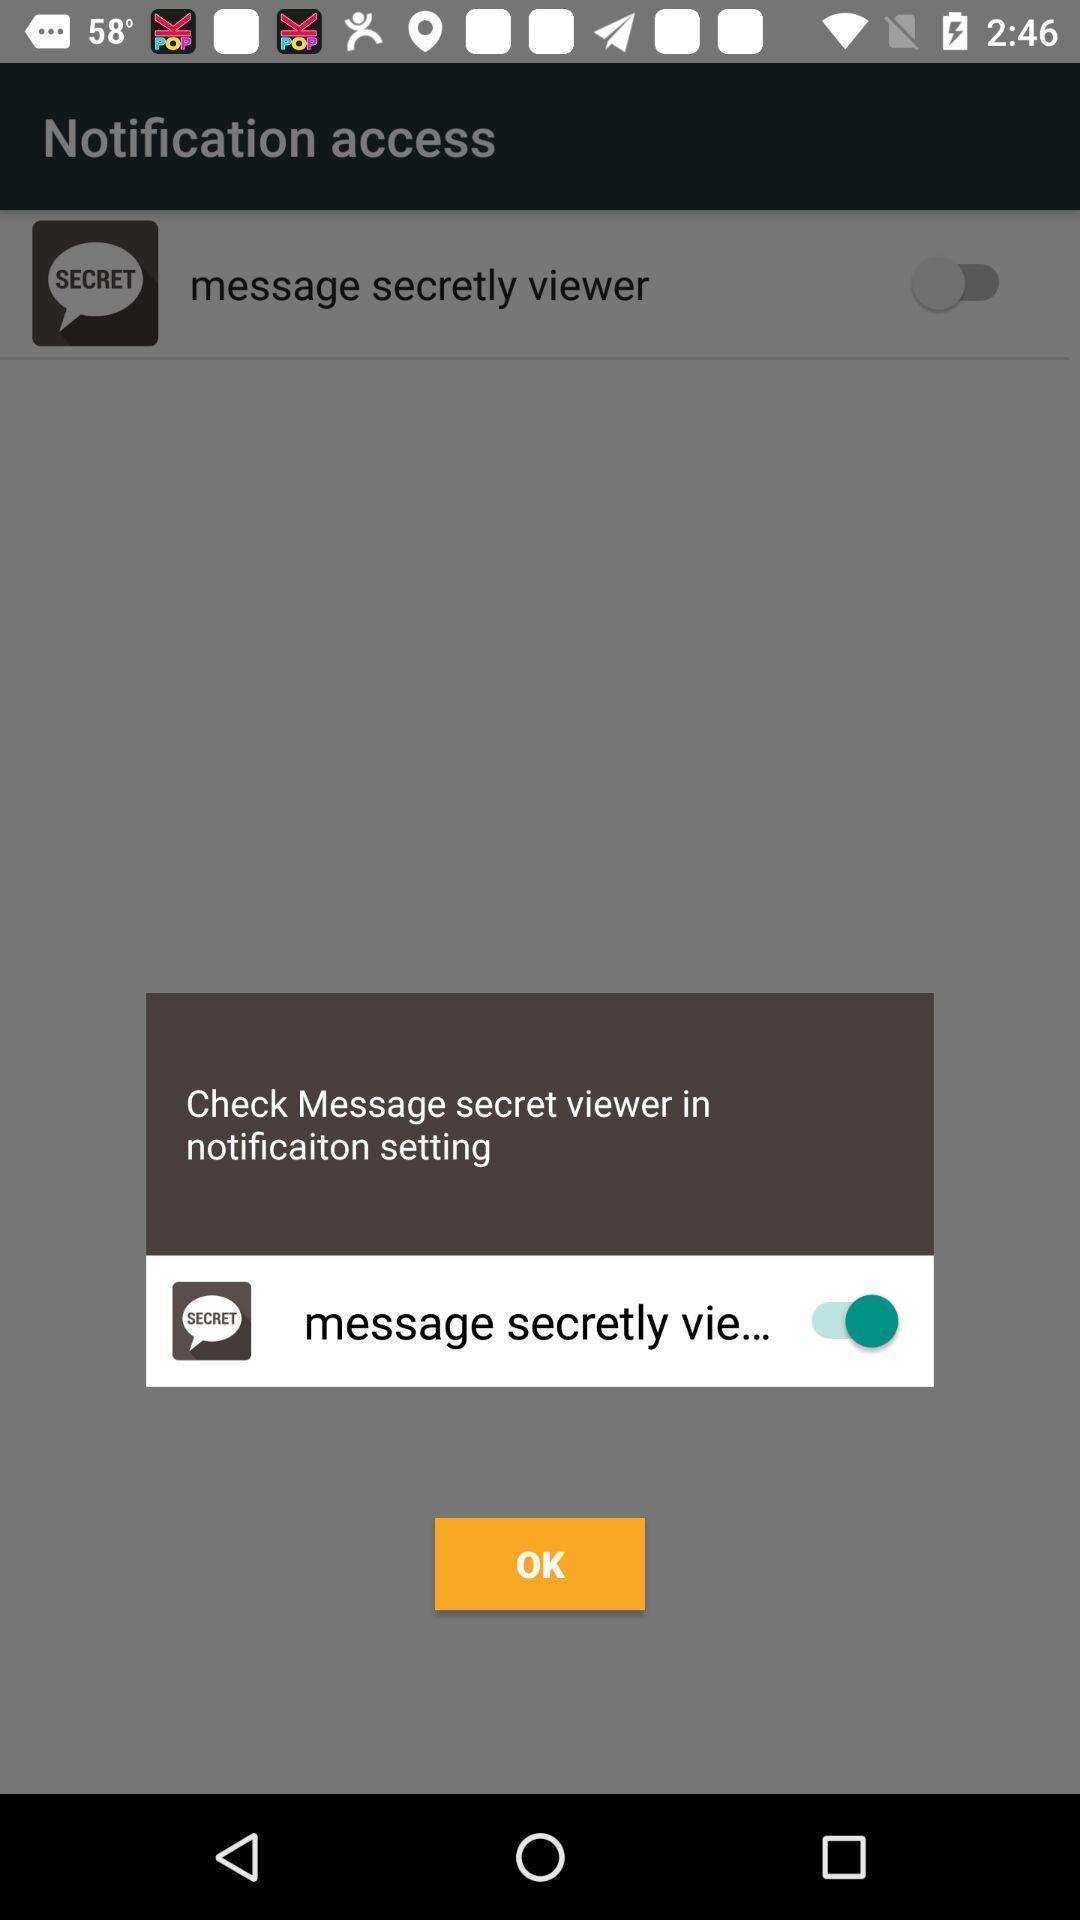What details can you identify in this image? Pop-up showing to select an option. 